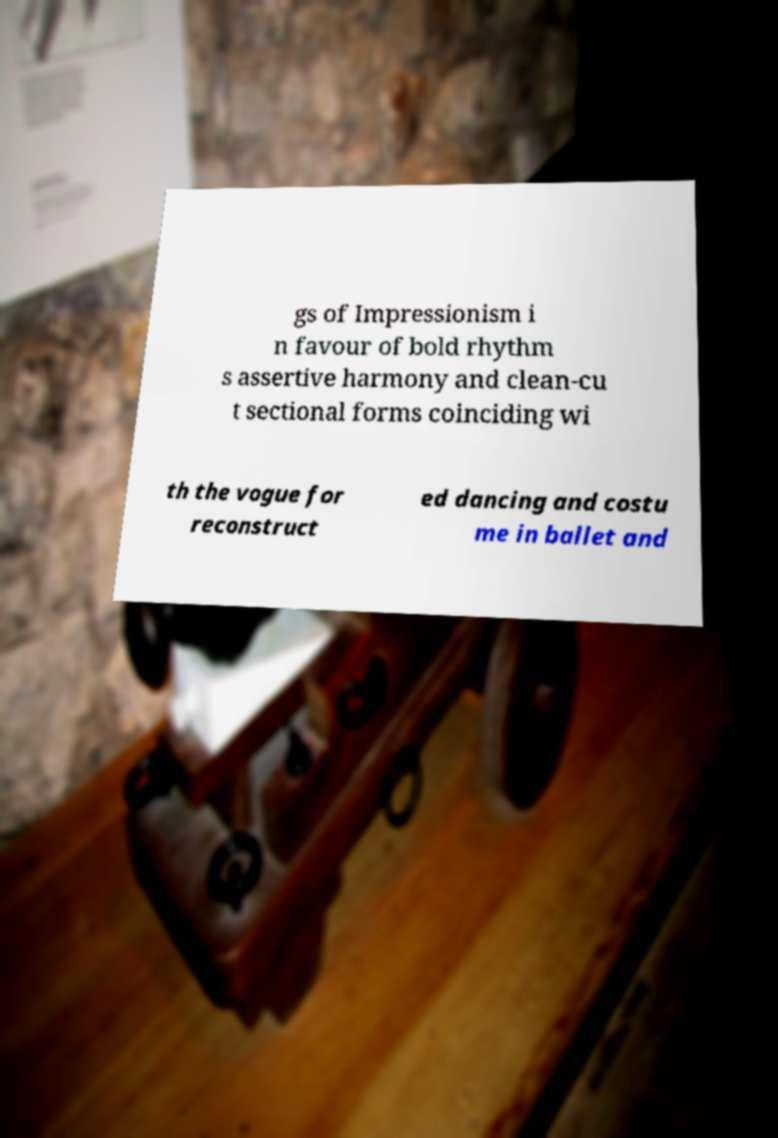Please read and relay the text visible in this image. What does it say? gs of Impressionism i n favour of bold rhythm s assertive harmony and clean-cu t sectional forms coinciding wi th the vogue for reconstruct ed dancing and costu me in ballet and 